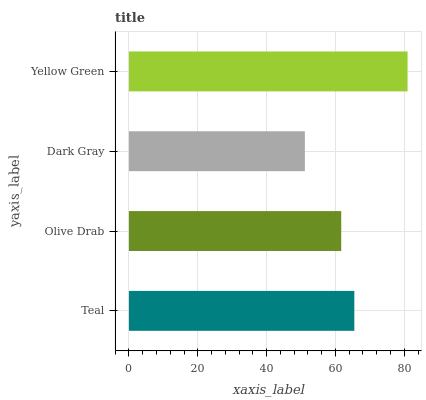Is Dark Gray the minimum?
Answer yes or no. Yes. Is Yellow Green the maximum?
Answer yes or no. Yes. Is Olive Drab the minimum?
Answer yes or no. No. Is Olive Drab the maximum?
Answer yes or no. No. Is Teal greater than Olive Drab?
Answer yes or no. Yes. Is Olive Drab less than Teal?
Answer yes or no. Yes. Is Olive Drab greater than Teal?
Answer yes or no. No. Is Teal less than Olive Drab?
Answer yes or no. No. Is Teal the high median?
Answer yes or no. Yes. Is Olive Drab the low median?
Answer yes or no. Yes. Is Olive Drab the high median?
Answer yes or no. No. Is Dark Gray the low median?
Answer yes or no. No. 